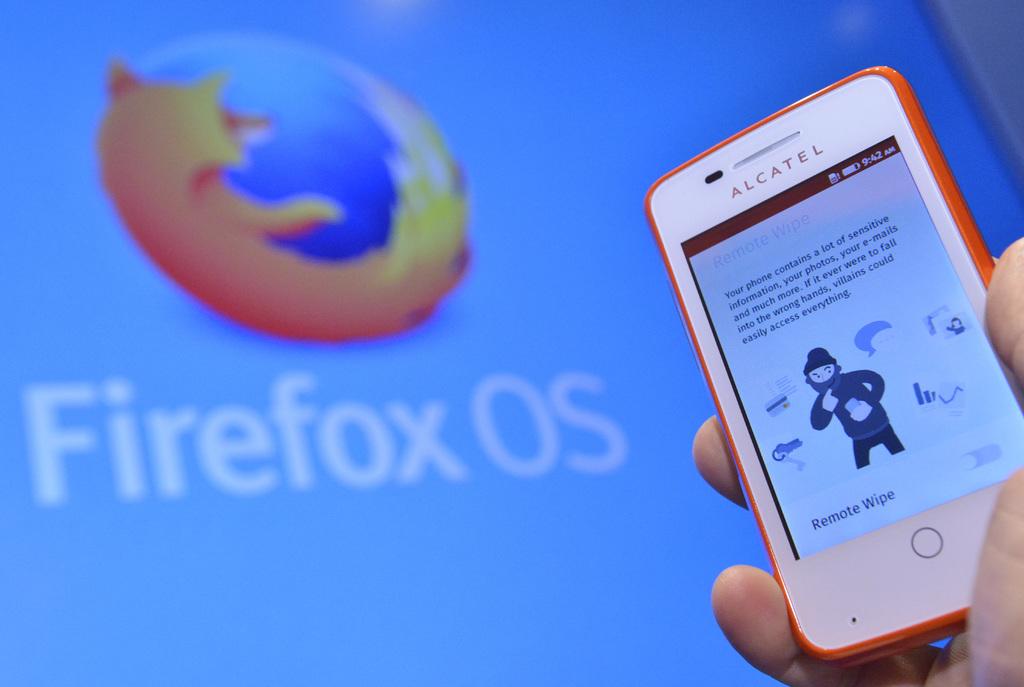What brand of phone is this?
Your response must be concise. Alcatel. What operating system is shown here?
Provide a succinct answer. Firefox. 